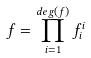Convert formula to latex. <formula><loc_0><loc_0><loc_500><loc_500>f = \prod _ { i = 1 } ^ { d e g ( f ) } f _ { i } ^ { i }</formula> 